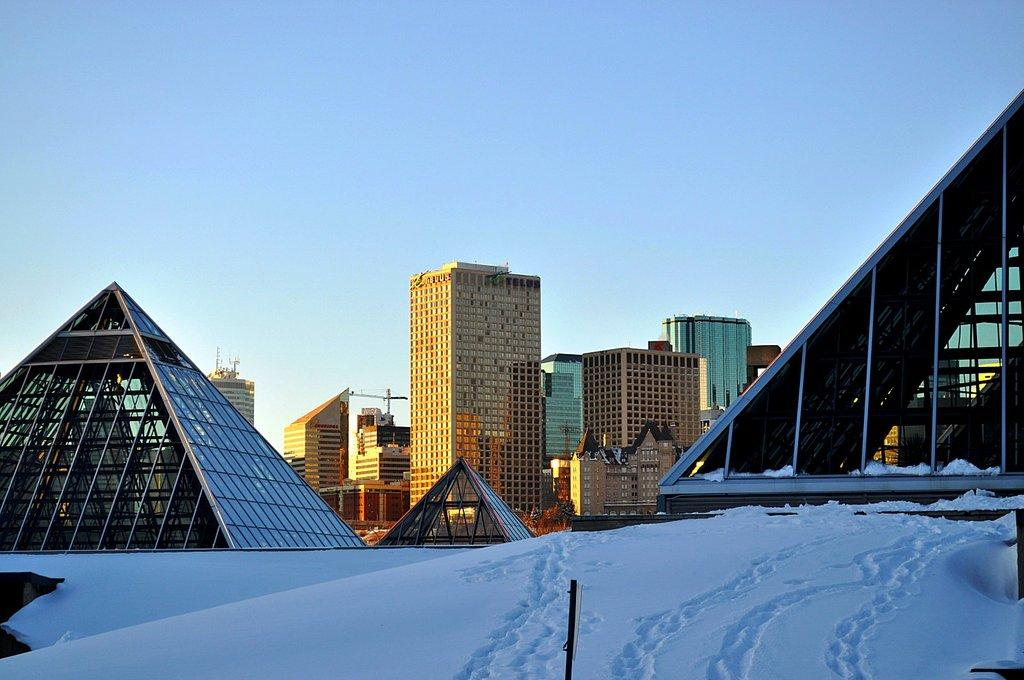What type of structures can be seen in the image? There are buildings, towers, and sheds in the image. What is the weather like in the image? Snow is visible at the bottom of the image, indicating a snowy or cold environment. What is located at the bottom of the image? There is a board visible at the bottom of the image. What is visible at the top of the image? The sky is visible at the top of the image. What type of plants can be seen growing on the cushion in the image? There is no cushion or plants present in the image. 